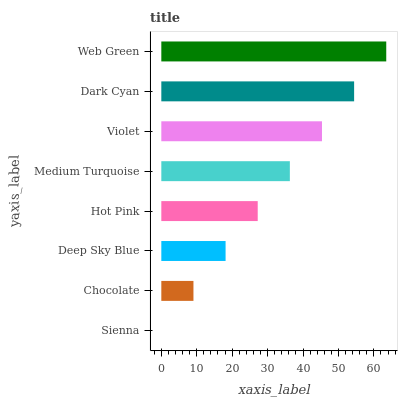Is Sienna the minimum?
Answer yes or no. Yes. Is Web Green the maximum?
Answer yes or no. Yes. Is Chocolate the minimum?
Answer yes or no. No. Is Chocolate the maximum?
Answer yes or no. No. Is Chocolate greater than Sienna?
Answer yes or no. Yes. Is Sienna less than Chocolate?
Answer yes or no. Yes. Is Sienna greater than Chocolate?
Answer yes or no. No. Is Chocolate less than Sienna?
Answer yes or no. No. Is Medium Turquoise the high median?
Answer yes or no. Yes. Is Hot Pink the low median?
Answer yes or no. Yes. Is Web Green the high median?
Answer yes or no. No. Is Violet the low median?
Answer yes or no. No. 